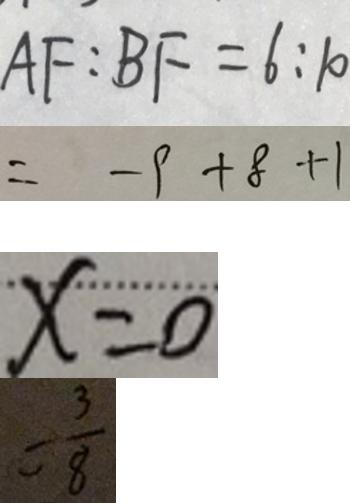<formula> <loc_0><loc_0><loc_500><loc_500>A F : B F = 6 : 1 0 
 = - 9 + 8 + 1 
 x = 0 
 = \frac { 3 } { 8 }</formula> 